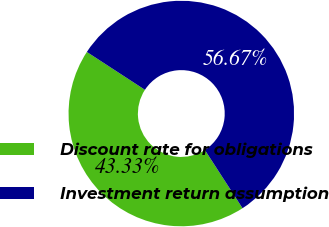Convert chart. <chart><loc_0><loc_0><loc_500><loc_500><pie_chart><fcel>Discount rate for obligations<fcel>Investment return assumption<nl><fcel>43.33%<fcel>56.67%<nl></chart> 